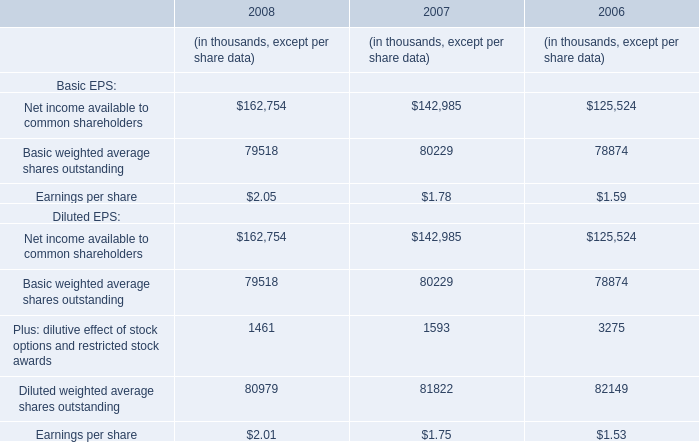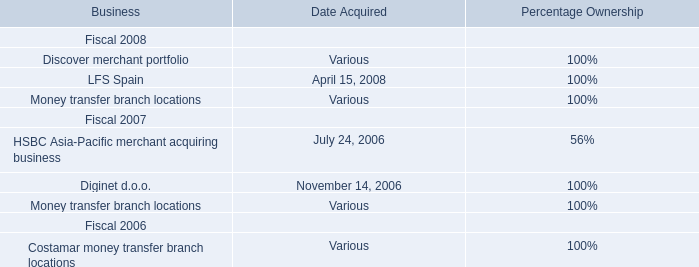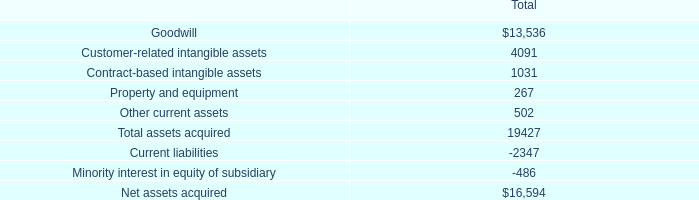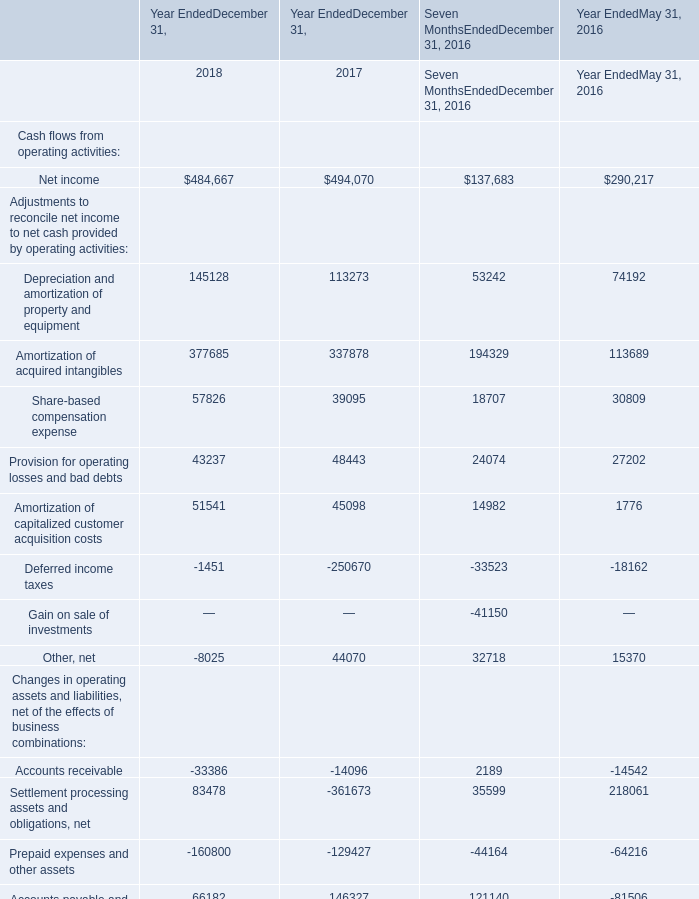What was the average of Net income in 2018, 2017, and 2016 ? 
Computations: ((((484667 + 494070) + 137683) + 290217) / 3)
Answer: 468879.0. 